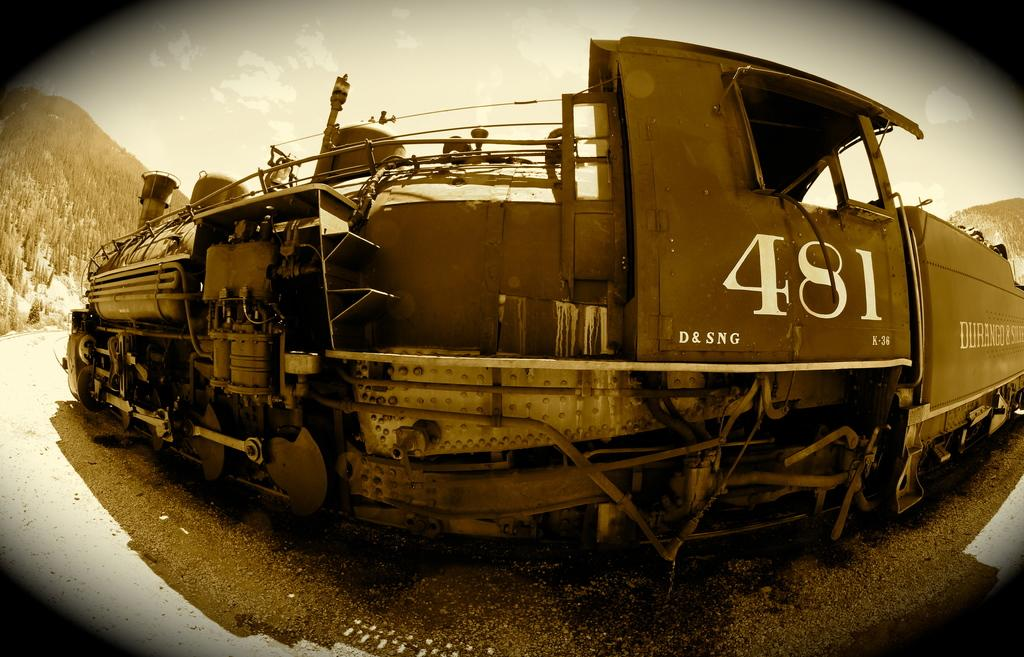<image>
Present a compact description of the photo's key features. A train has the number 481 printed near the engineer's compartment. 